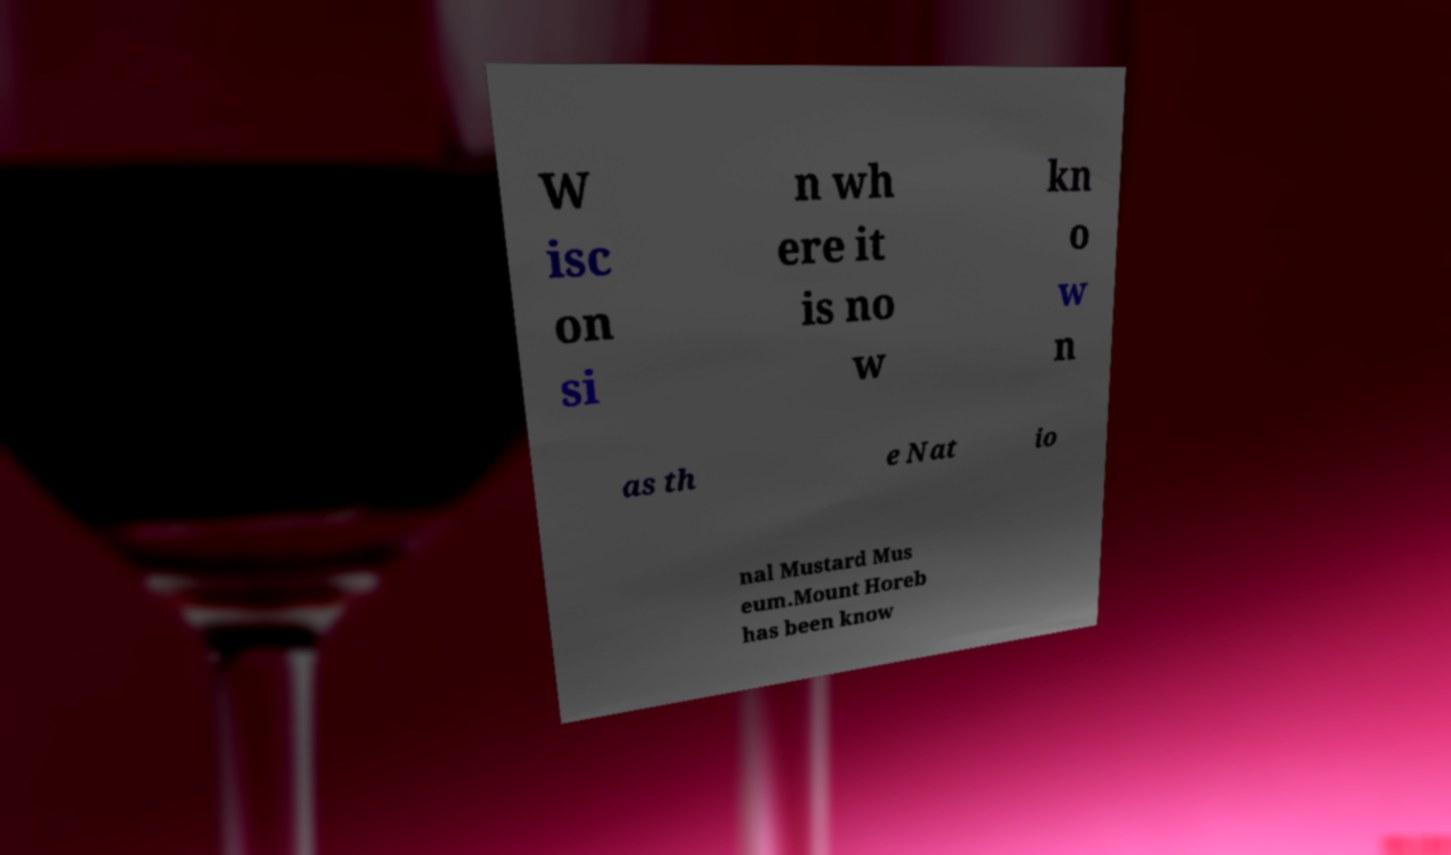I need the written content from this picture converted into text. Can you do that? W isc on si n wh ere it is no w kn o w n as th e Nat io nal Mustard Mus eum.Mount Horeb has been know 